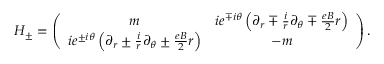<formula> <loc_0><loc_0><loc_500><loc_500>H _ { \pm } = \left ( \begin{array} { c c } { m } & { { i e ^ { \mp i \theta } \left ( \partial _ { r } \mp \frac { i } { r } \partial _ { \theta } \mp \frac { e B } { 2 } r \right ) } } \\ { { i e ^ { \pm i \theta } \left ( \partial _ { r } \pm \frac { i } { r } \partial _ { \theta } \pm \frac { e B } { 2 } r \right ) } } & { - m } \end{array} \right ) .</formula> 